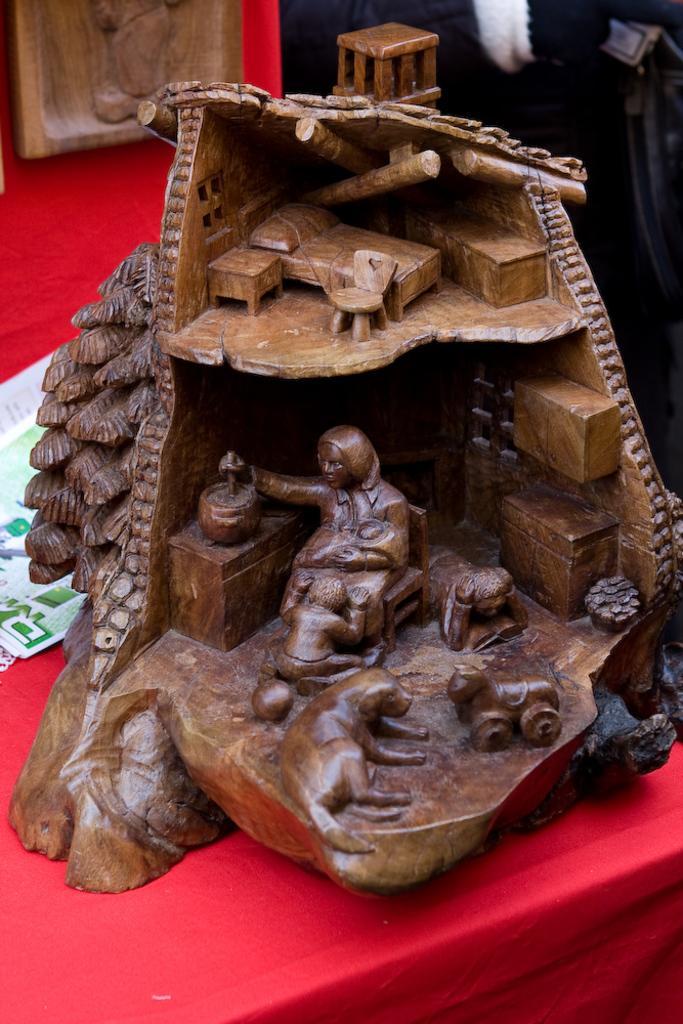Can you describe this image briefly? In this image I see the sculptures which are of brown in color and they're on the red color cloth and I see it is black over here and I see the white color thing over here and I see a paper over here. 